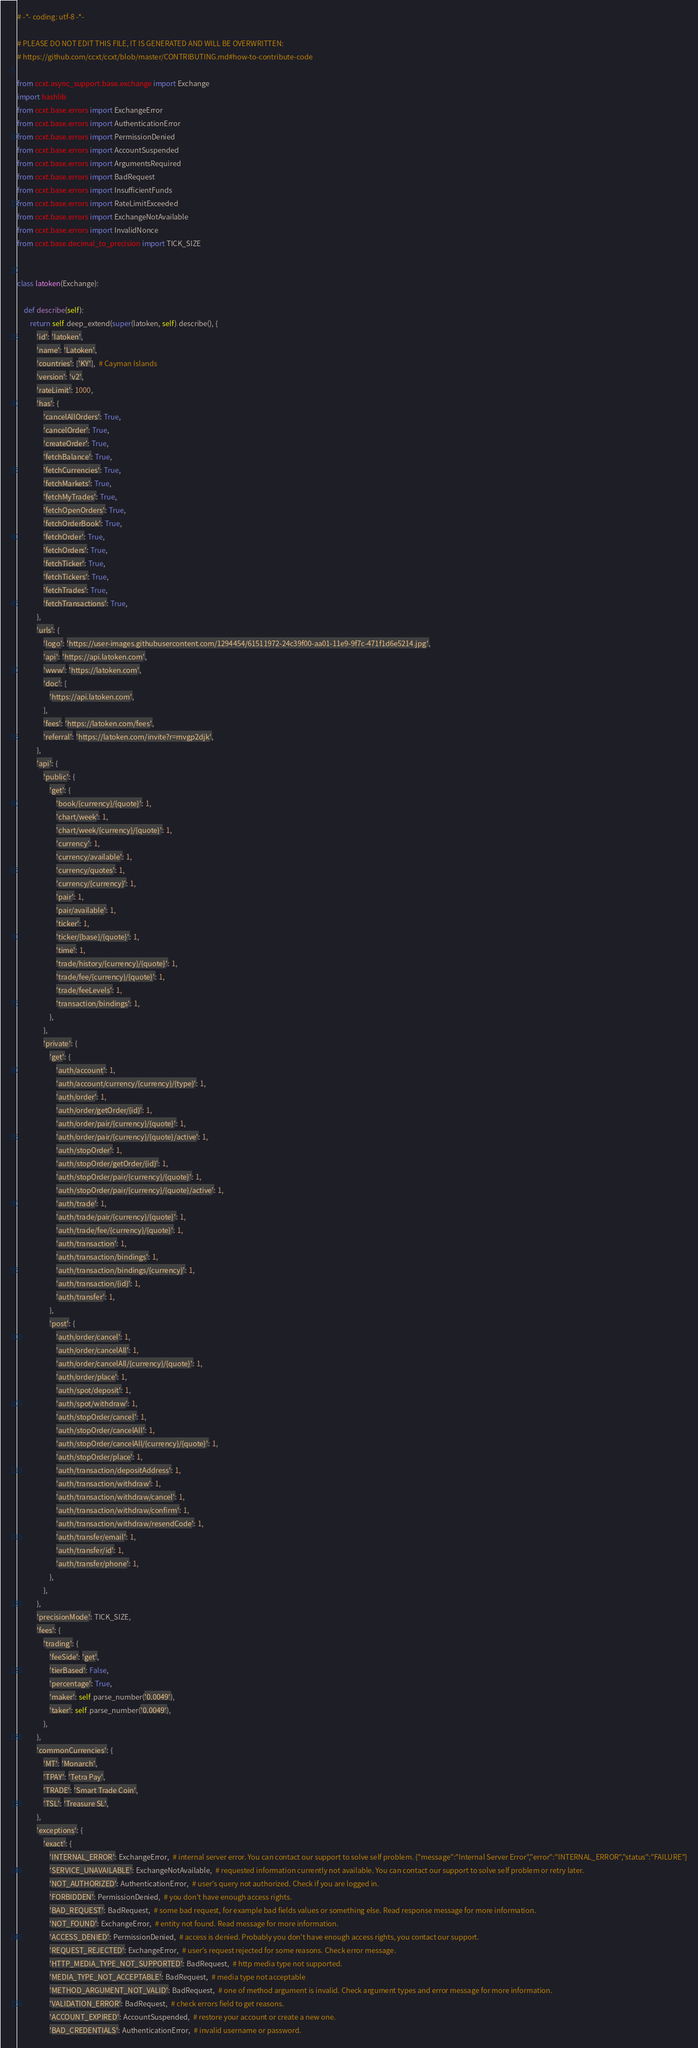Convert code to text. <code><loc_0><loc_0><loc_500><loc_500><_Python_># -*- coding: utf-8 -*-

# PLEASE DO NOT EDIT THIS FILE, IT IS GENERATED AND WILL BE OVERWRITTEN:
# https://github.com/ccxt/ccxt/blob/master/CONTRIBUTING.md#how-to-contribute-code

from ccxt.async_support.base.exchange import Exchange
import hashlib
from ccxt.base.errors import ExchangeError
from ccxt.base.errors import AuthenticationError
from ccxt.base.errors import PermissionDenied
from ccxt.base.errors import AccountSuspended
from ccxt.base.errors import ArgumentsRequired
from ccxt.base.errors import BadRequest
from ccxt.base.errors import InsufficientFunds
from ccxt.base.errors import RateLimitExceeded
from ccxt.base.errors import ExchangeNotAvailable
from ccxt.base.errors import InvalidNonce
from ccxt.base.decimal_to_precision import TICK_SIZE


class latoken(Exchange):

    def describe(self):
        return self.deep_extend(super(latoken, self).describe(), {
            'id': 'latoken',
            'name': 'Latoken',
            'countries': ['KY'],  # Cayman Islands
            'version': 'v2',
            'rateLimit': 1000,
            'has': {
                'cancelAllOrders': True,
                'cancelOrder': True,
                'createOrder': True,
                'fetchBalance': True,
                'fetchCurrencies': True,
                'fetchMarkets': True,
                'fetchMyTrades': True,
                'fetchOpenOrders': True,
                'fetchOrderBook': True,
                'fetchOrder': True,
                'fetchOrders': True,
                'fetchTicker': True,
                'fetchTickers': True,
                'fetchTrades': True,
                'fetchTransactions': True,
            },
            'urls': {
                'logo': 'https://user-images.githubusercontent.com/1294454/61511972-24c39f00-aa01-11e9-9f7c-471f1d6e5214.jpg',
                'api': 'https://api.latoken.com',
                'www': 'https://latoken.com',
                'doc': [
                    'https://api.latoken.com',
                ],
                'fees': 'https://latoken.com/fees',
                'referral': 'https://latoken.com/invite?r=mvgp2djk',
            },
            'api': {
                'public': {
                    'get': {
                        'book/{currency}/{quote}': 1,
                        'chart/week': 1,
                        'chart/week/{currency}/{quote}': 1,
                        'currency': 1,
                        'currency/available': 1,
                        'currency/quotes': 1,
                        'currency/{currency}': 1,
                        'pair': 1,
                        'pair/available': 1,
                        'ticker': 1,
                        'ticker/{base}/{quote}': 1,
                        'time': 1,
                        'trade/history/{currency}/{quote}': 1,
                        'trade/fee/{currency}/{quote}': 1,
                        'trade/feeLevels': 1,
                        'transaction/bindings': 1,
                    },
                },
                'private': {
                    'get': {
                        'auth/account': 1,
                        'auth/account/currency/{currency}/{type}': 1,
                        'auth/order': 1,
                        'auth/order/getOrder/{id}': 1,
                        'auth/order/pair/{currency}/{quote}': 1,
                        'auth/order/pair/{currency}/{quote}/active': 1,
                        'auth/stopOrder': 1,
                        'auth/stopOrder/getOrder/{id}': 1,
                        'auth/stopOrder/pair/{currency}/{quote}': 1,
                        'auth/stopOrder/pair/{currency}/{quote}/active': 1,
                        'auth/trade': 1,
                        'auth/trade/pair/{currency}/{quote}': 1,
                        'auth/trade/fee/{currency}/{quote}': 1,
                        'auth/transaction': 1,
                        'auth/transaction/bindings': 1,
                        'auth/transaction/bindings/{currency}': 1,
                        'auth/transaction/{id}': 1,
                        'auth/transfer': 1,
                    },
                    'post': {
                        'auth/order/cancel': 1,
                        'auth/order/cancelAll': 1,
                        'auth/order/cancelAll/{currency}/{quote}': 1,
                        'auth/order/place': 1,
                        'auth/spot/deposit': 1,
                        'auth/spot/withdraw': 1,
                        'auth/stopOrder/cancel': 1,
                        'auth/stopOrder/cancelAll': 1,
                        'auth/stopOrder/cancelAll/{currency}/{quote}': 1,
                        'auth/stopOrder/place': 1,
                        'auth/transaction/depositAddress': 1,
                        'auth/transaction/withdraw': 1,
                        'auth/transaction/withdraw/cancel': 1,
                        'auth/transaction/withdraw/confirm': 1,
                        'auth/transaction/withdraw/resendCode': 1,
                        'auth/transfer/email': 1,
                        'auth/transfer/id': 1,
                        'auth/transfer/phone': 1,
                    },
                },
            },
            'precisionMode': TICK_SIZE,
            'fees': {
                'trading': {
                    'feeSide': 'get',
                    'tierBased': False,
                    'percentage': True,
                    'maker': self.parse_number('0.0049'),
                    'taker': self.parse_number('0.0049'),
                },
            },
            'commonCurrencies': {
                'MT': 'Monarch',
                'TPAY': 'Tetra Pay',
                'TRADE': 'Smart Trade Coin',
                'TSL': 'Treasure SL',
            },
            'exceptions': {
                'exact': {
                    'INTERNAL_ERROR': ExchangeError,  # internal server error. You can contact our support to solve self problem. {"message":"Internal Server Error","error":"INTERNAL_ERROR","status":"FAILURE"}
                    'SERVICE_UNAVAILABLE': ExchangeNotAvailable,  # requested information currently not available. You can contact our support to solve self problem or retry later.
                    'NOT_AUTHORIZED': AuthenticationError,  # user's query not authorized. Check if you are logged in.
                    'FORBIDDEN': PermissionDenied,  # you don't have enough access rights.
                    'BAD_REQUEST': BadRequest,  # some bad request, for example bad fields values or something else. Read response message for more information.
                    'NOT_FOUND': ExchangeError,  # entity not found. Read message for more information.
                    'ACCESS_DENIED': PermissionDenied,  # access is denied. Probably you don't have enough access rights, you contact our support.
                    'REQUEST_REJECTED': ExchangeError,  # user's request rejected for some reasons. Check error message.
                    'HTTP_MEDIA_TYPE_NOT_SUPPORTED': BadRequest,  # http media type not supported.
                    'MEDIA_TYPE_NOT_ACCEPTABLE': BadRequest,  # media type not acceptable
                    'METHOD_ARGUMENT_NOT_VALID': BadRequest,  # one of method argument is invalid. Check argument types and error message for more information.
                    'VALIDATION_ERROR': BadRequest,  # check errors field to get reasons.
                    'ACCOUNT_EXPIRED': AccountSuspended,  # restore your account or create a new one.
                    'BAD_CREDENTIALS': AuthenticationError,  # invalid username or password.</code> 